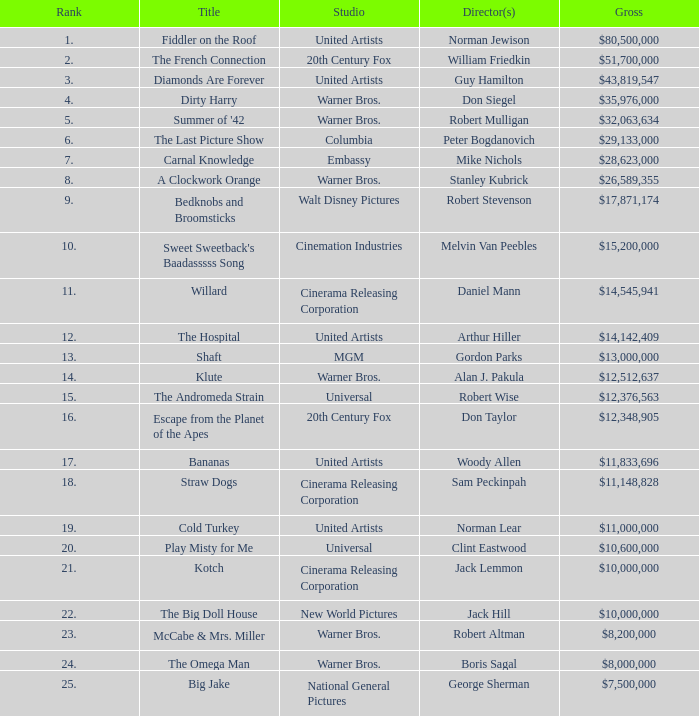Give me the full table as a dictionary. {'header': ['Rank', 'Title', 'Studio', 'Director(s)', 'Gross'], 'rows': [['1.', 'Fiddler on the Roof', 'United Artists', 'Norman Jewison', '$80,500,000'], ['2.', 'The French Connection', '20th Century Fox', 'William Friedkin', '$51,700,000'], ['3.', 'Diamonds Are Forever', 'United Artists', 'Guy Hamilton', '$43,819,547'], ['4.', 'Dirty Harry', 'Warner Bros.', 'Don Siegel', '$35,976,000'], ['5.', "Summer of '42", 'Warner Bros.', 'Robert Mulligan', '$32,063,634'], ['6.', 'The Last Picture Show', 'Columbia', 'Peter Bogdanovich', '$29,133,000'], ['7.', 'Carnal Knowledge', 'Embassy', 'Mike Nichols', '$28,623,000'], ['8.', 'A Clockwork Orange', 'Warner Bros.', 'Stanley Kubrick', '$26,589,355'], ['9.', 'Bedknobs and Broomsticks', 'Walt Disney Pictures', 'Robert Stevenson', '$17,871,174'], ['10.', "Sweet Sweetback's Baadasssss Song", 'Cinemation Industries', 'Melvin Van Peebles', '$15,200,000'], ['11.', 'Willard', 'Cinerama Releasing Corporation', 'Daniel Mann', '$14,545,941'], ['12.', 'The Hospital', 'United Artists', 'Arthur Hiller', '$14,142,409'], ['13.', 'Shaft', 'MGM', 'Gordon Parks', '$13,000,000'], ['14.', 'Klute', 'Warner Bros.', 'Alan J. Pakula', '$12,512,637'], ['15.', 'The Andromeda Strain', 'Universal', 'Robert Wise', '$12,376,563'], ['16.', 'Escape from the Planet of the Apes', '20th Century Fox', 'Don Taylor', '$12,348,905'], ['17.', 'Bananas', 'United Artists', 'Woody Allen', '$11,833,696'], ['18.', 'Straw Dogs', 'Cinerama Releasing Corporation', 'Sam Peckinpah', '$11,148,828'], ['19.', 'Cold Turkey', 'United Artists', 'Norman Lear', '$11,000,000'], ['20.', 'Play Misty for Me', 'Universal', 'Clint Eastwood', '$10,600,000'], ['21.', 'Kotch', 'Cinerama Releasing Corporation', 'Jack Lemmon', '$10,000,000'], ['22.', 'The Big Doll House', 'New World Pictures', 'Jack Hill', '$10,000,000'], ['23.', 'McCabe & Mrs. Miller', 'Warner Bros.', 'Robert Altman', '$8,200,000'], ['24.', 'The Omega Man', 'Warner Bros.', 'Boris Sagal', '$8,000,000'], ['25.', 'Big Jake', 'National General Pictures', 'George Sherman', '$7,500,000']]} What is the rank associated with $35,976,000 in gross? 4.0. 